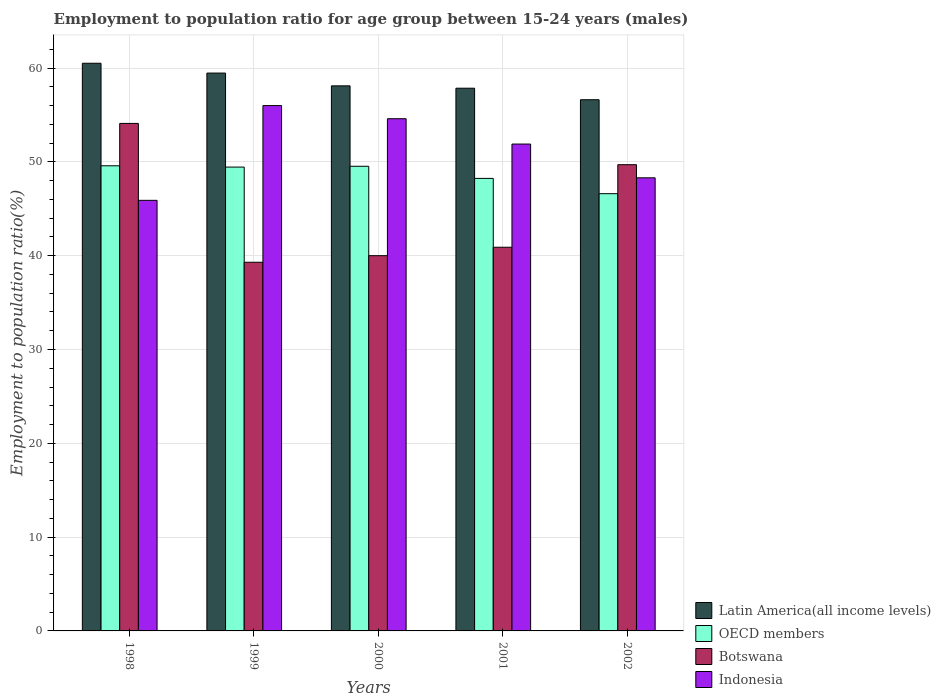How many different coloured bars are there?
Keep it short and to the point. 4. Are the number of bars on each tick of the X-axis equal?
Keep it short and to the point. Yes. What is the employment to population ratio in Botswana in 2000?
Your response must be concise. 40. Across all years, what is the maximum employment to population ratio in Indonesia?
Offer a very short reply. 56. Across all years, what is the minimum employment to population ratio in Latin America(all income levels)?
Provide a succinct answer. 56.62. In which year was the employment to population ratio in Botswana maximum?
Provide a short and direct response. 1998. What is the total employment to population ratio in OECD members in the graph?
Your answer should be very brief. 243.41. What is the difference between the employment to population ratio in Botswana in 1998 and that in 2000?
Offer a very short reply. 14.1. What is the difference between the employment to population ratio in Latin America(all income levels) in 2000 and the employment to population ratio in Botswana in 2002?
Make the answer very short. 8.41. What is the average employment to population ratio in OECD members per year?
Your response must be concise. 48.68. In the year 2002, what is the difference between the employment to population ratio in OECD members and employment to population ratio in Indonesia?
Offer a very short reply. -1.69. What is the ratio of the employment to population ratio in Botswana in 1998 to that in 2001?
Your answer should be very brief. 1.32. Is the employment to population ratio in Latin America(all income levels) in 1999 less than that in 2000?
Provide a short and direct response. No. Is the difference between the employment to population ratio in OECD members in 2001 and 2002 greater than the difference between the employment to population ratio in Indonesia in 2001 and 2002?
Your answer should be compact. No. What is the difference between the highest and the second highest employment to population ratio in Latin America(all income levels)?
Make the answer very short. 1.05. What is the difference between the highest and the lowest employment to population ratio in Indonesia?
Provide a succinct answer. 10.1. What does the 1st bar from the left in 2000 represents?
Give a very brief answer. Latin America(all income levels). What does the 3rd bar from the right in 1998 represents?
Make the answer very short. OECD members. Is it the case that in every year, the sum of the employment to population ratio in Botswana and employment to population ratio in OECD members is greater than the employment to population ratio in Indonesia?
Provide a short and direct response. Yes. How many years are there in the graph?
Give a very brief answer. 5. Where does the legend appear in the graph?
Provide a succinct answer. Bottom right. How many legend labels are there?
Ensure brevity in your answer.  4. What is the title of the graph?
Ensure brevity in your answer.  Employment to population ratio for age group between 15-24 years (males). What is the label or title of the Y-axis?
Give a very brief answer. Employment to population ratio(%). What is the Employment to population ratio(%) in Latin America(all income levels) in 1998?
Your answer should be very brief. 60.51. What is the Employment to population ratio(%) of OECD members in 1998?
Your response must be concise. 49.58. What is the Employment to population ratio(%) of Botswana in 1998?
Your answer should be compact. 54.1. What is the Employment to population ratio(%) of Indonesia in 1998?
Keep it short and to the point. 45.9. What is the Employment to population ratio(%) in Latin America(all income levels) in 1999?
Ensure brevity in your answer.  59.47. What is the Employment to population ratio(%) of OECD members in 1999?
Your answer should be very brief. 49.44. What is the Employment to population ratio(%) in Botswana in 1999?
Offer a terse response. 39.3. What is the Employment to population ratio(%) in Latin America(all income levels) in 2000?
Ensure brevity in your answer.  58.11. What is the Employment to population ratio(%) in OECD members in 2000?
Provide a succinct answer. 49.53. What is the Employment to population ratio(%) of Botswana in 2000?
Offer a terse response. 40. What is the Employment to population ratio(%) of Indonesia in 2000?
Your response must be concise. 54.6. What is the Employment to population ratio(%) of Latin America(all income levels) in 2001?
Keep it short and to the point. 57.85. What is the Employment to population ratio(%) of OECD members in 2001?
Offer a terse response. 48.24. What is the Employment to population ratio(%) in Botswana in 2001?
Give a very brief answer. 40.9. What is the Employment to population ratio(%) of Indonesia in 2001?
Offer a very short reply. 51.9. What is the Employment to population ratio(%) in Latin America(all income levels) in 2002?
Your response must be concise. 56.62. What is the Employment to population ratio(%) of OECD members in 2002?
Give a very brief answer. 46.61. What is the Employment to population ratio(%) of Botswana in 2002?
Offer a very short reply. 49.7. What is the Employment to population ratio(%) of Indonesia in 2002?
Offer a very short reply. 48.3. Across all years, what is the maximum Employment to population ratio(%) of Latin America(all income levels)?
Make the answer very short. 60.51. Across all years, what is the maximum Employment to population ratio(%) of OECD members?
Your answer should be very brief. 49.58. Across all years, what is the maximum Employment to population ratio(%) in Botswana?
Keep it short and to the point. 54.1. Across all years, what is the maximum Employment to population ratio(%) of Indonesia?
Your response must be concise. 56. Across all years, what is the minimum Employment to population ratio(%) of Latin America(all income levels)?
Ensure brevity in your answer.  56.62. Across all years, what is the minimum Employment to population ratio(%) of OECD members?
Offer a terse response. 46.61. Across all years, what is the minimum Employment to population ratio(%) in Botswana?
Offer a very short reply. 39.3. Across all years, what is the minimum Employment to population ratio(%) of Indonesia?
Provide a succinct answer. 45.9. What is the total Employment to population ratio(%) in Latin America(all income levels) in the graph?
Offer a terse response. 292.56. What is the total Employment to population ratio(%) in OECD members in the graph?
Ensure brevity in your answer.  243.41. What is the total Employment to population ratio(%) in Botswana in the graph?
Keep it short and to the point. 224. What is the total Employment to population ratio(%) in Indonesia in the graph?
Your response must be concise. 256.7. What is the difference between the Employment to population ratio(%) of Latin America(all income levels) in 1998 and that in 1999?
Your response must be concise. 1.05. What is the difference between the Employment to population ratio(%) in OECD members in 1998 and that in 1999?
Keep it short and to the point. 0.14. What is the difference between the Employment to population ratio(%) of Botswana in 1998 and that in 1999?
Provide a short and direct response. 14.8. What is the difference between the Employment to population ratio(%) of Indonesia in 1998 and that in 1999?
Offer a terse response. -10.1. What is the difference between the Employment to population ratio(%) of Latin America(all income levels) in 1998 and that in 2000?
Make the answer very short. 2.41. What is the difference between the Employment to population ratio(%) of OECD members in 1998 and that in 2000?
Your answer should be very brief. 0.05. What is the difference between the Employment to population ratio(%) of Botswana in 1998 and that in 2000?
Make the answer very short. 14.1. What is the difference between the Employment to population ratio(%) in Indonesia in 1998 and that in 2000?
Provide a short and direct response. -8.7. What is the difference between the Employment to population ratio(%) of Latin America(all income levels) in 1998 and that in 2001?
Offer a terse response. 2.66. What is the difference between the Employment to population ratio(%) of OECD members in 1998 and that in 2001?
Provide a succinct answer. 1.34. What is the difference between the Employment to population ratio(%) in Botswana in 1998 and that in 2001?
Provide a succinct answer. 13.2. What is the difference between the Employment to population ratio(%) of Indonesia in 1998 and that in 2001?
Ensure brevity in your answer.  -6. What is the difference between the Employment to population ratio(%) of Latin America(all income levels) in 1998 and that in 2002?
Provide a succinct answer. 3.89. What is the difference between the Employment to population ratio(%) in OECD members in 1998 and that in 2002?
Give a very brief answer. 2.97. What is the difference between the Employment to population ratio(%) in Latin America(all income levels) in 1999 and that in 2000?
Make the answer very short. 1.36. What is the difference between the Employment to population ratio(%) of OECD members in 1999 and that in 2000?
Give a very brief answer. -0.09. What is the difference between the Employment to population ratio(%) of Latin America(all income levels) in 1999 and that in 2001?
Provide a short and direct response. 1.61. What is the difference between the Employment to population ratio(%) in OECD members in 1999 and that in 2001?
Provide a succinct answer. 1.21. What is the difference between the Employment to population ratio(%) in Indonesia in 1999 and that in 2001?
Make the answer very short. 4.1. What is the difference between the Employment to population ratio(%) in Latin America(all income levels) in 1999 and that in 2002?
Your answer should be compact. 2.84. What is the difference between the Employment to population ratio(%) in OECD members in 1999 and that in 2002?
Your answer should be compact. 2.83. What is the difference between the Employment to population ratio(%) in Botswana in 1999 and that in 2002?
Keep it short and to the point. -10.4. What is the difference between the Employment to population ratio(%) of Indonesia in 1999 and that in 2002?
Provide a short and direct response. 7.7. What is the difference between the Employment to population ratio(%) in Latin America(all income levels) in 2000 and that in 2001?
Ensure brevity in your answer.  0.25. What is the difference between the Employment to population ratio(%) in OECD members in 2000 and that in 2001?
Offer a terse response. 1.29. What is the difference between the Employment to population ratio(%) of Botswana in 2000 and that in 2001?
Offer a very short reply. -0.9. What is the difference between the Employment to population ratio(%) in Indonesia in 2000 and that in 2001?
Your answer should be compact. 2.7. What is the difference between the Employment to population ratio(%) in Latin America(all income levels) in 2000 and that in 2002?
Offer a terse response. 1.48. What is the difference between the Employment to population ratio(%) in OECD members in 2000 and that in 2002?
Your answer should be compact. 2.92. What is the difference between the Employment to population ratio(%) of Indonesia in 2000 and that in 2002?
Provide a short and direct response. 6.3. What is the difference between the Employment to population ratio(%) of Latin America(all income levels) in 2001 and that in 2002?
Make the answer very short. 1.23. What is the difference between the Employment to population ratio(%) of OECD members in 2001 and that in 2002?
Keep it short and to the point. 1.63. What is the difference between the Employment to population ratio(%) of Botswana in 2001 and that in 2002?
Give a very brief answer. -8.8. What is the difference between the Employment to population ratio(%) of Latin America(all income levels) in 1998 and the Employment to population ratio(%) of OECD members in 1999?
Your answer should be very brief. 11.07. What is the difference between the Employment to population ratio(%) in Latin America(all income levels) in 1998 and the Employment to population ratio(%) in Botswana in 1999?
Keep it short and to the point. 21.21. What is the difference between the Employment to population ratio(%) of Latin America(all income levels) in 1998 and the Employment to population ratio(%) of Indonesia in 1999?
Provide a short and direct response. 4.51. What is the difference between the Employment to population ratio(%) of OECD members in 1998 and the Employment to population ratio(%) of Botswana in 1999?
Give a very brief answer. 10.28. What is the difference between the Employment to population ratio(%) in OECD members in 1998 and the Employment to population ratio(%) in Indonesia in 1999?
Keep it short and to the point. -6.42. What is the difference between the Employment to population ratio(%) in Latin America(all income levels) in 1998 and the Employment to population ratio(%) in OECD members in 2000?
Ensure brevity in your answer.  10.98. What is the difference between the Employment to population ratio(%) in Latin America(all income levels) in 1998 and the Employment to population ratio(%) in Botswana in 2000?
Offer a terse response. 20.51. What is the difference between the Employment to population ratio(%) in Latin America(all income levels) in 1998 and the Employment to population ratio(%) in Indonesia in 2000?
Offer a very short reply. 5.91. What is the difference between the Employment to population ratio(%) of OECD members in 1998 and the Employment to population ratio(%) of Botswana in 2000?
Keep it short and to the point. 9.58. What is the difference between the Employment to population ratio(%) in OECD members in 1998 and the Employment to population ratio(%) in Indonesia in 2000?
Provide a succinct answer. -5.02. What is the difference between the Employment to population ratio(%) in Botswana in 1998 and the Employment to population ratio(%) in Indonesia in 2000?
Provide a succinct answer. -0.5. What is the difference between the Employment to population ratio(%) of Latin America(all income levels) in 1998 and the Employment to population ratio(%) of OECD members in 2001?
Ensure brevity in your answer.  12.27. What is the difference between the Employment to population ratio(%) of Latin America(all income levels) in 1998 and the Employment to population ratio(%) of Botswana in 2001?
Provide a succinct answer. 19.61. What is the difference between the Employment to population ratio(%) in Latin America(all income levels) in 1998 and the Employment to population ratio(%) in Indonesia in 2001?
Give a very brief answer. 8.61. What is the difference between the Employment to population ratio(%) of OECD members in 1998 and the Employment to population ratio(%) of Botswana in 2001?
Provide a succinct answer. 8.68. What is the difference between the Employment to population ratio(%) in OECD members in 1998 and the Employment to population ratio(%) in Indonesia in 2001?
Give a very brief answer. -2.32. What is the difference between the Employment to population ratio(%) in Botswana in 1998 and the Employment to population ratio(%) in Indonesia in 2001?
Your answer should be very brief. 2.2. What is the difference between the Employment to population ratio(%) in Latin America(all income levels) in 1998 and the Employment to population ratio(%) in OECD members in 2002?
Make the answer very short. 13.9. What is the difference between the Employment to population ratio(%) of Latin America(all income levels) in 1998 and the Employment to population ratio(%) of Botswana in 2002?
Your answer should be compact. 10.81. What is the difference between the Employment to population ratio(%) in Latin America(all income levels) in 1998 and the Employment to population ratio(%) in Indonesia in 2002?
Your answer should be very brief. 12.21. What is the difference between the Employment to population ratio(%) of OECD members in 1998 and the Employment to population ratio(%) of Botswana in 2002?
Ensure brevity in your answer.  -0.12. What is the difference between the Employment to population ratio(%) in OECD members in 1998 and the Employment to population ratio(%) in Indonesia in 2002?
Your response must be concise. 1.28. What is the difference between the Employment to population ratio(%) in Botswana in 1998 and the Employment to population ratio(%) in Indonesia in 2002?
Give a very brief answer. 5.8. What is the difference between the Employment to population ratio(%) in Latin America(all income levels) in 1999 and the Employment to population ratio(%) in OECD members in 2000?
Your response must be concise. 9.94. What is the difference between the Employment to population ratio(%) of Latin America(all income levels) in 1999 and the Employment to population ratio(%) of Botswana in 2000?
Your response must be concise. 19.47. What is the difference between the Employment to population ratio(%) of Latin America(all income levels) in 1999 and the Employment to population ratio(%) of Indonesia in 2000?
Provide a short and direct response. 4.87. What is the difference between the Employment to population ratio(%) of OECD members in 1999 and the Employment to population ratio(%) of Botswana in 2000?
Provide a succinct answer. 9.44. What is the difference between the Employment to population ratio(%) in OECD members in 1999 and the Employment to population ratio(%) in Indonesia in 2000?
Provide a succinct answer. -5.16. What is the difference between the Employment to population ratio(%) of Botswana in 1999 and the Employment to population ratio(%) of Indonesia in 2000?
Make the answer very short. -15.3. What is the difference between the Employment to population ratio(%) in Latin America(all income levels) in 1999 and the Employment to population ratio(%) in OECD members in 2001?
Your response must be concise. 11.23. What is the difference between the Employment to population ratio(%) in Latin America(all income levels) in 1999 and the Employment to population ratio(%) in Botswana in 2001?
Offer a very short reply. 18.57. What is the difference between the Employment to population ratio(%) of Latin America(all income levels) in 1999 and the Employment to population ratio(%) of Indonesia in 2001?
Provide a short and direct response. 7.57. What is the difference between the Employment to population ratio(%) in OECD members in 1999 and the Employment to population ratio(%) in Botswana in 2001?
Offer a very short reply. 8.54. What is the difference between the Employment to population ratio(%) of OECD members in 1999 and the Employment to population ratio(%) of Indonesia in 2001?
Make the answer very short. -2.46. What is the difference between the Employment to population ratio(%) in Botswana in 1999 and the Employment to population ratio(%) in Indonesia in 2001?
Your response must be concise. -12.6. What is the difference between the Employment to population ratio(%) of Latin America(all income levels) in 1999 and the Employment to population ratio(%) of OECD members in 2002?
Your response must be concise. 12.86. What is the difference between the Employment to population ratio(%) in Latin America(all income levels) in 1999 and the Employment to population ratio(%) in Botswana in 2002?
Provide a succinct answer. 9.77. What is the difference between the Employment to population ratio(%) of Latin America(all income levels) in 1999 and the Employment to population ratio(%) of Indonesia in 2002?
Your response must be concise. 11.17. What is the difference between the Employment to population ratio(%) of OECD members in 1999 and the Employment to population ratio(%) of Botswana in 2002?
Your answer should be compact. -0.26. What is the difference between the Employment to population ratio(%) in OECD members in 1999 and the Employment to population ratio(%) in Indonesia in 2002?
Ensure brevity in your answer.  1.14. What is the difference between the Employment to population ratio(%) of Botswana in 1999 and the Employment to population ratio(%) of Indonesia in 2002?
Ensure brevity in your answer.  -9. What is the difference between the Employment to population ratio(%) in Latin America(all income levels) in 2000 and the Employment to population ratio(%) in OECD members in 2001?
Your response must be concise. 9.87. What is the difference between the Employment to population ratio(%) of Latin America(all income levels) in 2000 and the Employment to population ratio(%) of Botswana in 2001?
Give a very brief answer. 17.2. What is the difference between the Employment to population ratio(%) in Latin America(all income levels) in 2000 and the Employment to population ratio(%) in Indonesia in 2001?
Make the answer very short. 6.21. What is the difference between the Employment to population ratio(%) in OECD members in 2000 and the Employment to population ratio(%) in Botswana in 2001?
Offer a very short reply. 8.63. What is the difference between the Employment to population ratio(%) in OECD members in 2000 and the Employment to population ratio(%) in Indonesia in 2001?
Offer a very short reply. -2.37. What is the difference between the Employment to population ratio(%) in Latin America(all income levels) in 2000 and the Employment to population ratio(%) in OECD members in 2002?
Your answer should be compact. 11.5. What is the difference between the Employment to population ratio(%) in Latin America(all income levels) in 2000 and the Employment to population ratio(%) in Botswana in 2002?
Give a very brief answer. 8.4. What is the difference between the Employment to population ratio(%) of Latin America(all income levels) in 2000 and the Employment to population ratio(%) of Indonesia in 2002?
Provide a short and direct response. 9.8. What is the difference between the Employment to population ratio(%) of OECD members in 2000 and the Employment to population ratio(%) of Botswana in 2002?
Provide a succinct answer. -0.17. What is the difference between the Employment to population ratio(%) of OECD members in 2000 and the Employment to population ratio(%) of Indonesia in 2002?
Offer a terse response. 1.23. What is the difference between the Employment to population ratio(%) of Latin America(all income levels) in 2001 and the Employment to population ratio(%) of OECD members in 2002?
Your answer should be compact. 11.24. What is the difference between the Employment to population ratio(%) of Latin America(all income levels) in 2001 and the Employment to population ratio(%) of Botswana in 2002?
Give a very brief answer. 8.15. What is the difference between the Employment to population ratio(%) of Latin America(all income levels) in 2001 and the Employment to population ratio(%) of Indonesia in 2002?
Your response must be concise. 9.55. What is the difference between the Employment to population ratio(%) of OECD members in 2001 and the Employment to population ratio(%) of Botswana in 2002?
Give a very brief answer. -1.46. What is the difference between the Employment to population ratio(%) of OECD members in 2001 and the Employment to population ratio(%) of Indonesia in 2002?
Offer a terse response. -0.06. What is the average Employment to population ratio(%) of Latin America(all income levels) per year?
Your response must be concise. 58.51. What is the average Employment to population ratio(%) of OECD members per year?
Keep it short and to the point. 48.68. What is the average Employment to population ratio(%) in Botswana per year?
Offer a terse response. 44.8. What is the average Employment to population ratio(%) of Indonesia per year?
Give a very brief answer. 51.34. In the year 1998, what is the difference between the Employment to population ratio(%) in Latin America(all income levels) and Employment to population ratio(%) in OECD members?
Your answer should be very brief. 10.93. In the year 1998, what is the difference between the Employment to population ratio(%) in Latin America(all income levels) and Employment to population ratio(%) in Botswana?
Keep it short and to the point. 6.41. In the year 1998, what is the difference between the Employment to population ratio(%) in Latin America(all income levels) and Employment to population ratio(%) in Indonesia?
Provide a succinct answer. 14.61. In the year 1998, what is the difference between the Employment to population ratio(%) of OECD members and Employment to population ratio(%) of Botswana?
Make the answer very short. -4.52. In the year 1998, what is the difference between the Employment to population ratio(%) of OECD members and Employment to population ratio(%) of Indonesia?
Keep it short and to the point. 3.68. In the year 1998, what is the difference between the Employment to population ratio(%) of Botswana and Employment to population ratio(%) of Indonesia?
Offer a very short reply. 8.2. In the year 1999, what is the difference between the Employment to population ratio(%) of Latin America(all income levels) and Employment to population ratio(%) of OECD members?
Provide a short and direct response. 10.02. In the year 1999, what is the difference between the Employment to population ratio(%) in Latin America(all income levels) and Employment to population ratio(%) in Botswana?
Provide a succinct answer. 20.17. In the year 1999, what is the difference between the Employment to population ratio(%) of Latin America(all income levels) and Employment to population ratio(%) of Indonesia?
Provide a succinct answer. 3.47. In the year 1999, what is the difference between the Employment to population ratio(%) of OECD members and Employment to population ratio(%) of Botswana?
Your answer should be very brief. 10.14. In the year 1999, what is the difference between the Employment to population ratio(%) in OECD members and Employment to population ratio(%) in Indonesia?
Give a very brief answer. -6.56. In the year 1999, what is the difference between the Employment to population ratio(%) in Botswana and Employment to population ratio(%) in Indonesia?
Offer a terse response. -16.7. In the year 2000, what is the difference between the Employment to population ratio(%) of Latin America(all income levels) and Employment to population ratio(%) of OECD members?
Make the answer very short. 8.57. In the year 2000, what is the difference between the Employment to population ratio(%) in Latin America(all income levels) and Employment to population ratio(%) in Botswana?
Make the answer very short. 18.11. In the year 2000, what is the difference between the Employment to population ratio(%) of Latin America(all income levels) and Employment to population ratio(%) of Indonesia?
Your response must be concise. 3.5. In the year 2000, what is the difference between the Employment to population ratio(%) of OECD members and Employment to population ratio(%) of Botswana?
Ensure brevity in your answer.  9.53. In the year 2000, what is the difference between the Employment to population ratio(%) in OECD members and Employment to population ratio(%) in Indonesia?
Make the answer very short. -5.07. In the year 2000, what is the difference between the Employment to population ratio(%) of Botswana and Employment to population ratio(%) of Indonesia?
Your answer should be compact. -14.6. In the year 2001, what is the difference between the Employment to population ratio(%) of Latin America(all income levels) and Employment to population ratio(%) of OECD members?
Make the answer very short. 9.61. In the year 2001, what is the difference between the Employment to population ratio(%) in Latin America(all income levels) and Employment to population ratio(%) in Botswana?
Ensure brevity in your answer.  16.95. In the year 2001, what is the difference between the Employment to population ratio(%) of Latin America(all income levels) and Employment to population ratio(%) of Indonesia?
Your answer should be very brief. 5.95. In the year 2001, what is the difference between the Employment to population ratio(%) of OECD members and Employment to population ratio(%) of Botswana?
Ensure brevity in your answer.  7.34. In the year 2001, what is the difference between the Employment to population ratio(%) of OECD members and Employment to population ratio(%) of Indonesia?
Provide a short and direct response. -3.66. In the year 2001, what is the difference between the Employment to population ratio(%) of Botswana and Employment to population ratio(%) of Indonesia?
Give a very brief answer. -11. In the year 2002, what is the difference between the Employment to population ratio(%) of Latin America(all income levels) and Employment to population ratio(%) of OECD members?
Give a very brief answer. 10.01. In the year 2002, what is the difference between the Employment to population ratio(%) of Latin America(all income levels) and Employment to population ratio(%) of Botswana?
Offer a very short reply. 6.92. In the year 2002, what is the difference between the Employment to population ratio(%) in Latin America(all income levels) and Employment to population ratio(%) in Indonesia?
Offer a very short reply. 8.32. In the year 2002, what is the difference between the Employment to population ratio(%) of OECD members and Employment to population ratio(%) of Botswana?
Give a very brief answer. -3.09. In the year 2002, what is the difference between the Employment to population ratio(%) in OECD members and Employment to population ratio(%) in Indonesia?
Offer a terse response. -1.69. In the year 2002, what is the difference between the Employment to population ratio(%) of Botswana and Employment to population ratio(%) of Indonesia?
Offer a very short reply. 1.4. What is the ratio of the Employment to population ratio(%) of Latin America(all income levels) in 1998 to that in 1999?
Your response must be concise. 1.02. What is the ratio of the Employment to population ratio(%) in Botswana in 1998 to that in 1999?
Keep it short and to the point. 1.38. What is the ratio of the Employment to population ratio(%) of Indonesia in 1998 to that in 1999?
Provide a succinct answer. 0.82. What is the ratio of the Employment to population ratio(%) of Latin America(all income levels) in 1998 to that in 2000?
Your answer should be compact. 1.04. What is the ratio of the Employment to population ratio(%) of OECD members in 1998 to that in 2000?
Offer a terse response. 1. What is the ratio of the Employment to population ratio(%) of Botswana in 1998 to that in 2000?
Keep it short and to the point. 1.35. What is the ratio of the Employment to population ratio(%) in Indonesia in 1998 to that in 2000?
Your answer should be compact. 0.84. What is the ratio of the Employment to population ratio(%) of Latin America(all income levels) in 1998 to that in 2001?
Your answer should be compact. 1.05. What is the ratio of the Employment to population ratio(%) in OECD members in 1998 to that in 2001?
Offer a very short reply. 1.03. What is the ratio of the Employment to population ratio(%) in Botswana in 1998 to that in 2001?
Give a very brief answer. 1.32. What is the ratio of the Employment to population ratio(%) of Indonesia in 1998 to that in 2001?
Ensure brevity in your answer.  0.88. What is the ratio of the Employment to population ratio(%) of Latin America(all income levels) in 1998 to that in 2002?
Make the answer very short. 1.07. What is the ratio of the Employment to population ratio(%) in OECD members in 1998 to that in 2002?
Offer a terse response. 1.06. What is the ratio of the Employment to population ratio(%) in Botswana in 1998 to that in 2002?
Offer a terse response. 1.09. What is the ratio of the Employment to population ratio(%) of Indonesia in 1998 to that in 2002?
Keep it short and to the point. 0.95. What is the ratio of the Employment to population ratio(%) in Latin America(all income levels) in 1999 to that in 2000?
Offer a very short reply. 1.02. What is the ratio of the Employment to population ratio(%) of OECD members in 1999 to that in 2000?
Provide a succinct answer. 1. What is the ratio of the Employment to population ratio(%) in Botswana in 1999 to that in 2000?
Your response must be concise. 0.98. What is the ratio of the Employment to population ratio(%) of Indonesia in 1999 to that in 2000?
Provide a succinct answer. 1.03. What is the ratio of the Employment to population ratio(%) in Latin America(all income levels) in 1999 to that in 2001?
Your answer should be compact. 1.03. What is the ratio of the Employment to population ratio(%) of Botswana in 1999 to that in 2001?
Offer a very short reply. 0.96. What is the ratio of the Employment to population ratio(%) in Indonesia in 1999 to that in 2001?
Provide a succinct answer. 1.08. What is the ratio of the Employment to population ratio(%) in Latin America(all income levels) in 1999 to that in 2002?
Your answer should be compact. 1.05. What is the ratio of the Employment to population ratio(%) of OECD members in 1999 to that in 2002?
Offer a terse response. 1.06. What is the ratio of the Employment to population ratio(%) in Botswana in 1999 to that in 2002?
Ensure brevity in your answer.  0.79. What is the ratio of the Employment to population ratio(%) in Indonesia in 1999 to that in 2002?
Give a very brief answer. 1.16. What is the ratio of the Employment to population ratio(%) in Latin America(all income levels) in 2000 to that in 2001?
Offer a very short reply. 1. What is the ratio of the Employment to population ratio(%) of OECD members in 2000 to that in 2001?
Your answer should be very brief. 1.03. What is the ratio of the Employment to population ratio(%) in Indonesia in 2000 to that in 2001?
Your response must be concise. 1.05. What is the ratio of the Employment to population ratio(%) of Latin America(all income levels) in 2000 to that in 2002?
Your response must be concise. 1.03. What is the ratio of the Employment to population ratio(%) of OECD members in 2000 to that in 2002?
Your response must be concise. 1.06. What is the ratio of the Employment to population ratio(%) in Botswana in 2000 to that in 2002?
Provide a succinct answer. 0.8. What is the ratio of the Employment to population ratio(%) in Indonesia in 2000 to that in 2002?
Ensure brevity in your answer.  1.13. What is the ratio of the Employment to population ratio(%) in Latin America(all income levels) in 2001 to that in 2002?
Give a very brief answer. 1.02. What is the ratio of the Employment to population ratio(%) of OECD members in 2001 to that in 2002?
Provide a succinct answer. 1.03. What is the ratio of the Employment to population ratio(%) in Botswana in 2001 to that in 2002?
Provide a short and direct response. 0.82. What is the ratio of the Employment to population ratio(%) in Indonesia in 2001 to that in 2002?
Provide a short and direct response. 1.07. What is the difference between the highest and the second highest Employment to population ratio(%) in Latin America(all income levels)?
Offer a very short reply. 1.05. What is the difference between the highest and the second highest Employment to population ratio(%) in OECD members?
Provide a succinct answer. 0.05. What is the difference between the highest and the lowest Employment to population ratio(%) in Latin America(all income levels)?
Keep it short and to the point. 3.89. What is the difference between the highest and the lowest Employment to population ratio(%) in OECD members?
Your response must be concise. 2.97. What is the difference between the highest and the lowest Employment to population ratio(%) in Botswana?
Ensure brevity in your answer.  14.8. 